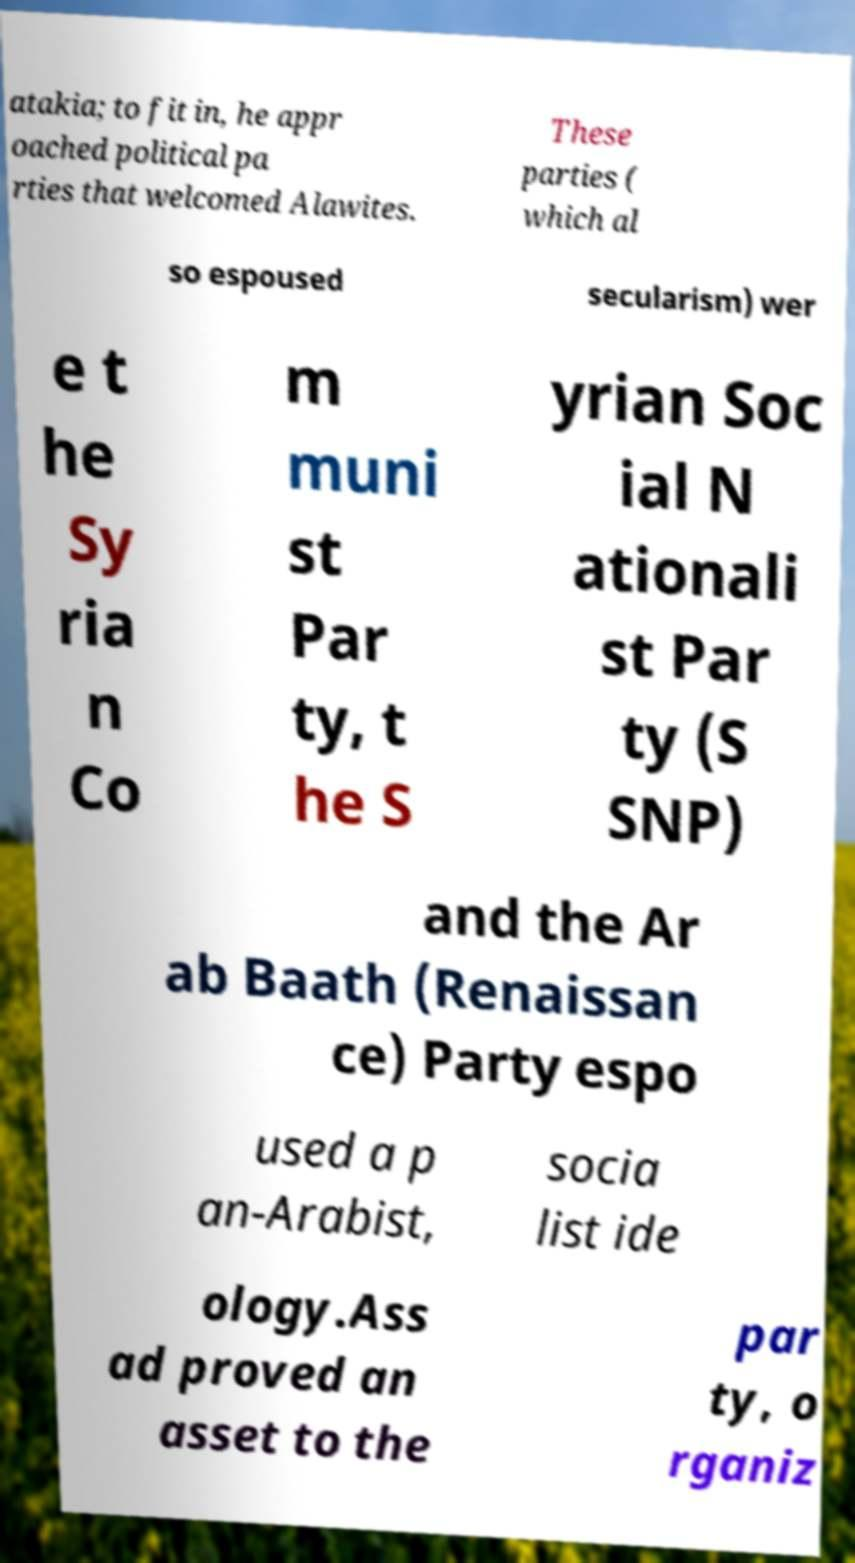Can you read and provide the text displayed in the image?This photo seems to have some interesting text. Can you extract and type it out for me? atakia; to fit in, he appr oached political pa rties that welcomed Alawites. These parties ( which al so espoused secularism) wer e t he Sy ria n Co m muni st Par ty, t he S yrian Soc ial N ationali st Par ty (S SNP) and the Ar ab Baath (Renaissan ce) Party espo used a p an-Arabist, socia list ide ology.Ass ad proved an asset to the par ty, o rganiz 